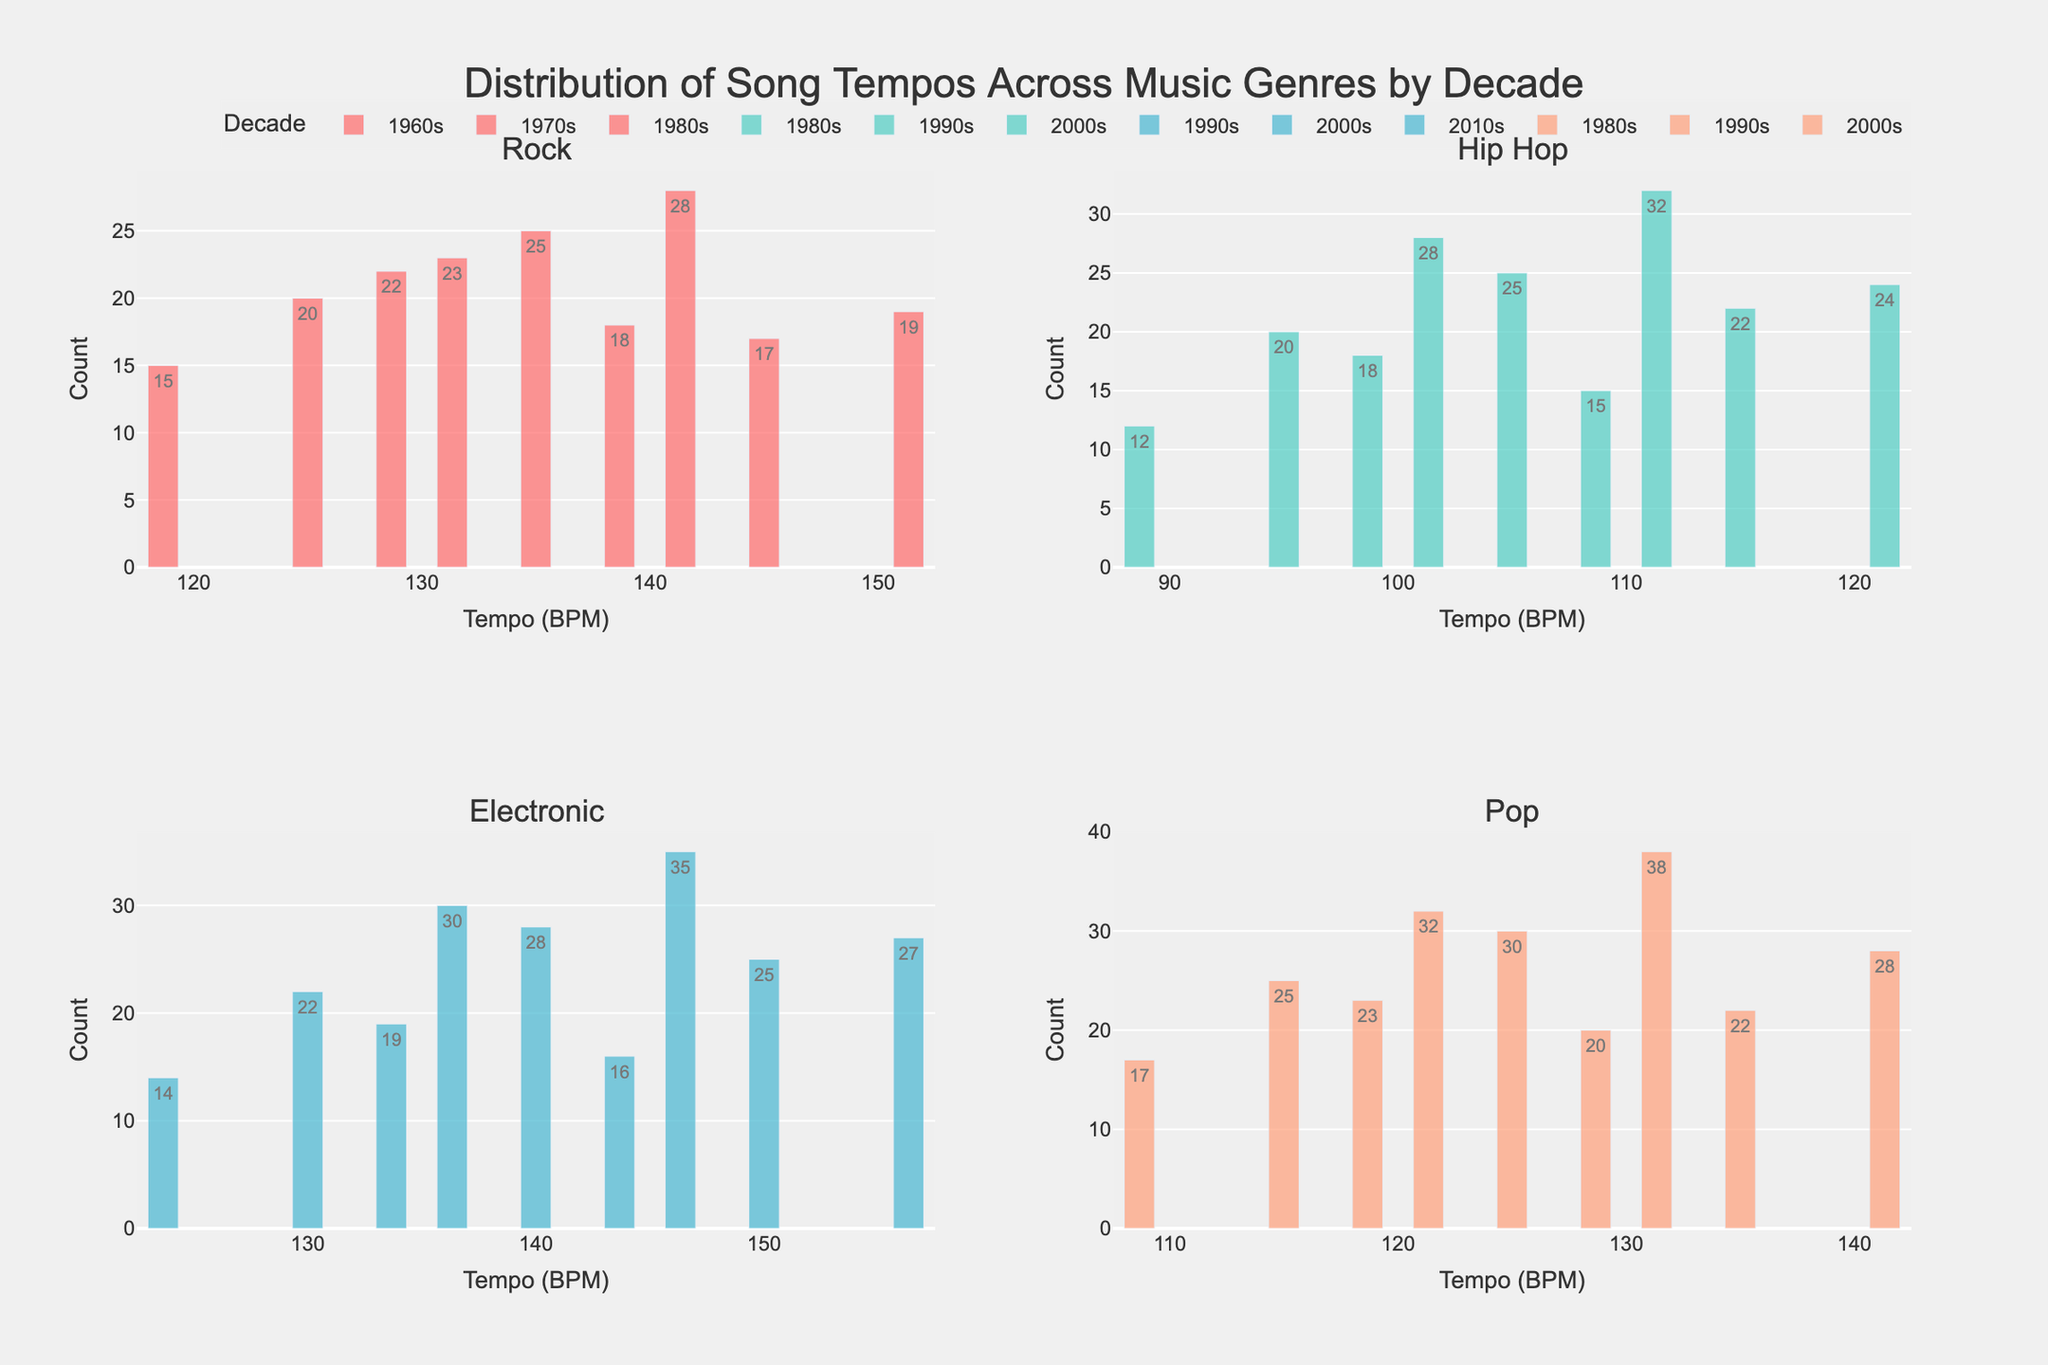What's the title of the figure? The title is typically located at the top of the figure, centered and often in a larger, bolder font to make it stand out.
Answer: Distribution of Song Tempos Across Music Genres by Decade What is the tempo range for Hip Hop in the 1990s? To find the tempo range, look for the lowest and highest values on the Tempo (BPM) axis for Hip Hop in the 1990s.
Answer: 95-115 BPM Which decade has the highest count of songs in the Electronic genre? Compare the heights of the bars for each decade in the Electronic genre subplot. The tallest bar represents the highest count.
Answer: 2010s How do the tempos in the 2000s Pop songs compare to those in the 1980s Pop songs? Observe the distributions of the bars in the Pop genre subplot for the 1980s and 2000s. Check both the tempo values and their counts.
Answer: The 2000s have higher tempos than the 1980s What is the maximum count of songs for any tempo in Rock during the 1980s? Identify the tallest bar in the Rock genre subplot within the 1980s section and read the count.
Answer: 28 How do the song counts for a tempo of 130 BPM in the 1980s compare between Rock and Pop genres? Look for the bar representing 130 BPM in the 1980s for both Rock and Pop genre subplots and compare their heights.
Answer: Rock: 23, Pop: 20 What tempo has the highest count in the 2000s Hip Hop songs? Identify the highest bar within the 2000s section of the Hip Hop genre subplot and check its corresponding tempo value on the x-axis.
Answer: 110 BPM How many different tempos are represented in the Electronic genre during the 1990s? Count the number of distinct bars in the 1990s section of the Electronic genre subplot.
Answer: 3 Which genre shows the widest range of tempos in any decade? Compare the range of tempos (difference between the highest and lowest tempo values) across all decades and genres.
Answer: Electronic (2010s) 